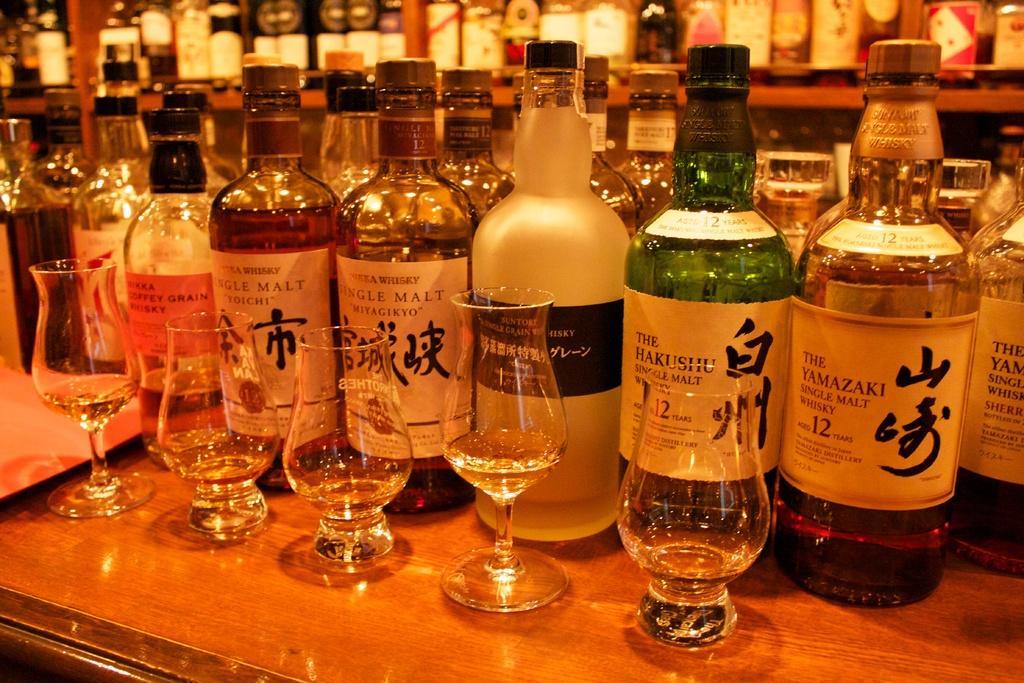Could you give a brief overview of what you see in this image? There are some wine bottles placed on the table along with some glasses here. In the background there is a shelf in which some wine bottles were placed. 